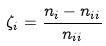<formula> <loc_0><loc_0><loc_500><loc_500>\zeta _ { i } = \frac { n _ { i } - n _ { i i } } { n _ { i i } }</formula> 